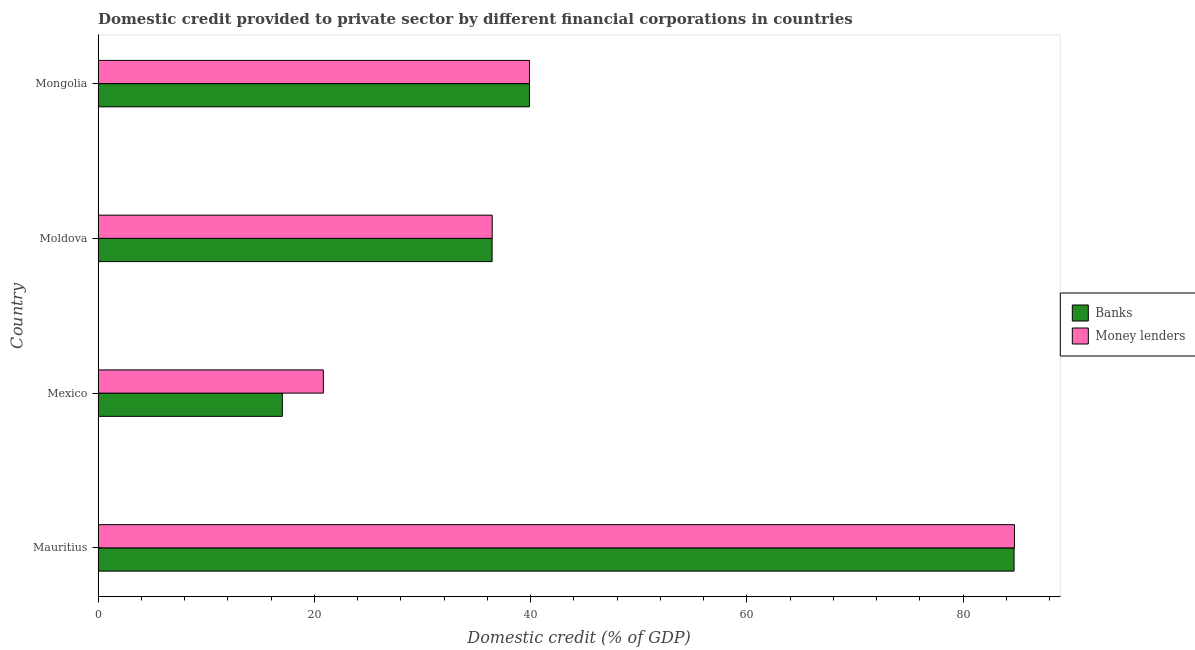How many different coloured bars are there?
Your response must be concise. 2. Are the number of bars per tick equal to the number of legend labels?
Your answer should be compact. Yes. How many bars are there on the 2nd tick from the top?
Your response must be concise. 2. How many bars are there on the 4th tick from the bottom?
Make the answer very short. 2. What is the label of the 1st group of bars from the top?
Give a very brief answer. Mongolia. What is the domestic credit provided by banks in Mongolia?
Give a very brief answer. 39.9. Across all countries, what is the maximum domestic credit provided by money lenders?
Your answer should be very brief. 84.76. Across all countries, what is the minimum domestic credit provided by banks?
Offer a terse response. 17.05. In which country was the domestic credit provided by banks maximum?
Ensure brevity in your answer.  Mauritius. What is the total domestic credit provided by banks in the graph?
Provide a short and direct response. 178.12. What is the difference between the domestic credit provided by banks in Moldova and that in Mongolia?
Your answer should be very brief. -3.46. What is the difference between the domestic credit provided by banks in Mexico and the domestic credit provided by money lenders in Moldova?
Your answer should be compact. -19.41. What is the average domestic credit provided by money lenders per country?
Give a very brief answer. 45.49. What is the difference between the domestic credit provided by banks and domestic credit provided by money lenders in Mongolia?
Offer a terse response. 0. What is the ratio of the domestic credit provided by money lenders in Mexico to that in Moldova?
Ensure brevity in your answer.  0.57. Is the domestic credit provided by money lenders in Mauritius less than that in Mongolia?
Give a very brief answer. No. What is the difference between the highest and the second highest domestic credit provided by banks?
Provide a short and direct response. 44.82. What is the difference between the highest and the lowest domestic credit provided by banks?
Make the answer very short. 67.68. In how many countries, is the domestic credit provided by money lenders greater than the average domestic credit provided by money lenders taken over all countries?
Provide a succinct answer. 1. Is the sum of the domestic credit provided by money lenders in Mauritius and Mexico greater than the maximum domestic credit provided by banks across all countries?
Provide a short and direct response. Yes. What does the 2nd bar from the top in Mauritius represents?
Your answer should be very brief. Banks. What does the 1st bar from the bottom in Mauritius represents?
Your answer should be very brief. Banks. How many bars are there?
Give a very brief answer. 8. Are the values on the major ticks of X-axis written in scientific E-notation?
Provide a short and direct response. No. Does the graph contain any zero values?
Give a very brief answer. No. Does the graph contain grids?
Provide a succinct answer. No. Where does the legend appear in the graph?
Your answer should be very brief. Center right. How many legend labels are there?
Offer a terse response. 2. How are the legend labels stacked?
Ensure brevity in your answer.  Vertical. What is the title of the graph?
Ensure brevity in your answer.  Domestic credit provided to private sector by different financial corporations in countries. Does "Under-five" appear as one of the legend labels in the graph?
Offer a terse response. No. What is the label or title of the X-axis?
Ensure brevity in your answer.  Domestic credit (% of GDP). What is the Domestic credit (% of GDP) in Banks in Mauritius?
Make the answer very short. 84.72. What is the Domestic credit (% of GDP) of Money lenders in Mauritius?
Give a very brief answer. 84.76. What is the Domestic credit (% of GDP) of Banks in Mexico?
Make the answer very short. 17.05. What is the Domestic credit (% of GDP) of Money lenders in Mexico?
Provide a succinct answer. 20.84. What is the Domestic credit (% of GDP) in Banks in Moldova?
Ensure brevity in your answer.  36.45. What is the Domestic credit (% of GDP) of Money lenders in Moldova?
Your response must be concise. 36.46. What is the Domestic credit (% of GDP) of Banks in Mongolia?
Make the answer very short. 39.9. What is the Domestic credit (% of GDP) in Money lenders in Mongolia?
Offer a terse response. 39.9. Across all countries, what is the maximum Domestic credit (% of GDP) in Banks?
Offer a very short reply. 84.72. Across all countries, what is the maximum Domestic credit (% of GDP) of Money lenders?
Ensure brevity in your answer.  84.76. Across all countries, what is the minimum Domestic credit (% of GDP) of Banks?
Provide a short and direct response. 17.05. Across all countries, what is the minimum Domestic credit (% of GDP) of Money lenders?
Your answer should be very brief. 20.84. What is the total Domestic credit (% of GDP) of Banks in the graph?
Provide a succinct answer. 178.12. What is the total Domestic credit (% of GDP) of Money lenders in the graph?
Offer a terse response. 181.96. What is the difference between the Domestic credit (% of GDP) in Banks in Mauritius and that in Mexico?
Your answer should be compact. 67.68. What is the difference between the Domestic credit (% of GDP) of Money lenders in Mauritius and that in Mexico?
Your answer should be compact. 63.92. What is the difference between the Domestic credit (% of GDP) of Banks in Mauritius and that in Moldova?
Provide a succinct answer. 48.28. What is the difference between the Domestic credit (% of GDP) of Money lenders in Mauritius and that in Moldova?
Your answer should be very brief. 48.31. What is the difference between the Domestic credit (% of GDP) in Banks in Mauritius and that in Mongolia?
Provide a short and direct response. 44.82. What is the difference between the Domestic credit (% of GDP) of Money lenders in Mauritius and that in Mongolia?
Offer a terse response. 44.86. What is the difference between the Domestic credit (% of GDP) of Banks in Mexico and that in Moldova?
Give a very brief answer. -19.4. What is the difference between the Domestic credit (% of GDP) in Money lenders in Mexico and that in Moldova?
Your response must be concise. -15.62. What is the difference between the Domestic credit (% of GDP) of Banks in Mexico and that in Mongolia?
Make the answer very short. -22.86. What is the difference between the Domestic credit (% of GDP) of Money lenders in Mexico and that in Mongolia?
Your response must be concise. -19.07. What is the difference between the Domestic credit (% of GDP) in Banks in Moldova and that in Mongolia?
Provide a succinct answer. -3.46. What is the difference between the Domestic credit (% of GDP) of Money lenders in Moldova and that in Mongolia?
Make the answer very short. -3.45. What is the difference between the Domestic credit (% of GDP) of Banks in Mauritius and the Domestic credit (% of GDP) of Money lenders in Mexico?
Keep it short and to the point. 63.89. What is the difference between the Domestic credit (% of GDP) of Banks in Mauritius and the Domestic credit (% of GDP) of Money lenders in Moldova?
Ensure brevity in your answer.  48.27. What is the difference between the Domestic credit (% of GDP) in Banks in Mauritius and the Domestic credit (% of GDP) in Money lenders in Mongolia?
Keep it short and to the point. 44.82. What is the difference between the Domestic credit (% of GDP) of Banks in Mexico and the Domestic credit (% of GDP) of Money lenders in Moldova?
Ensure brevity in your answer.  -19.41. What is the difference between the Domestic credit (% of GDP) in Banks in Mexico and the Domestic credit (% of GDP) in Money lenders in Mongolia?
Your response must be concise. -22.86. What is the difference between the Domestic credit (% of GDP) in Banks in Moldova and the Domestic credit (% of GDP) in Money lenders in Mongolia?
Offer a very short reply. -3.46. What is the average Domestic credit (% of GDP) of Banks per country?
Give a very brief answer. 44.53. What is the average Domestic credit (% of GDP) in Money lenders per country?
Provide a short and direct response. 45.49. What is the difference between the Domestic credit (% of GDP) of Banks and Domestic credit (% of GDP) of Money lenders in Mauritius?
Provide a short and direct response. -0.04. What is the difference between the Domestic credit (% of GDP) in Banks and Domestic credit (% of GDP) in Money lenders in Mexico?
Provide a short and direct response. -3.79. What is the difference between the Domestic credit (% of GDP) of Banks and Domestic credit (% of GDP) of Money lenders in Moldova?
Ensure brevity in your answer.  -0.01. What is the difference between the Domestic credit (% of GDP) in Banks and Domestic credit (% of GDP) in Money lenders in Mongolia?
Your answer should be compact. 0. What is the ratio of the Domestic credit (% of GDP) of Banks in Mauritius to that in Mexico?
Your answer should be very brief. 4.97. What is the ratio of the Domestic credit (% of GDP) of Money lenders in Mauritius to that in Mexico?
Make the answer very short. 4.07. What is the ratio of the Domestic credit (% of GDP) of Banks in Mauritius to that in Moldova?
Your response must be concise. 2.32. What is the ratio of the Domestic credit (% of GDP) of Money lenders in Mauritius to that in Moldova?
Keep it short and to the point. 2.33. What is the ratio of the Domestic credit (% of GDP) in Banks in Mauritius to that in Mongolia?
Offer a terse response. 2.12. What is the ratio of the Domestic credit (% of GDP) of Money lenders in Mauritius to that in Mongolia?
Your response must be concise. 2.12. What is the ratio of the Domestic credit (% of GDP) of Banks in Mexico to that in Moldova?
Keep it short and to the point. 0.47. What is the ratio of the Domestic credit (% of GDP) in Money lenders in Mexico to that in Moldova?
Make the answer very short. 0.57. What is the ratio of the Domestic credit (% of GDP) of Banks in Mexico to that in Mongolia?
Offer a very short reply. 0.43. What is the ratio of the Domestic credit (% of GDP) in Money lenders in Mexico to that in Mongolia?
Your response must be concise. 0.52. What is the ratio of the Domestic credit (% of GDP) in Banks in Moldova to that in Mongolia?
Ensure brevity in your answer.  0.91. What is the ratio of the Domestic credit (% of GDP) of Money lenders in Moldova to that in Mongolia?
Give a very brief answer. 0.91. What is the difference between the highest and the second highest Domestic credit (% of GDP) of Banks?
Make the answer very short. 44.82. What is the difference between the highest and the second highest Domestic credit (% of GDP) of Money lenders?
Offer a very short reply. 44.86. What is the difference between the highest and the lowest Domestic credit (% of GDP) in Banks?
Keep it short and to the point. 67.68. What is the difference between the highest and the lowest Domestic credit (% of GDP) in Money lenders?
Your response must be concise. 63.92. 